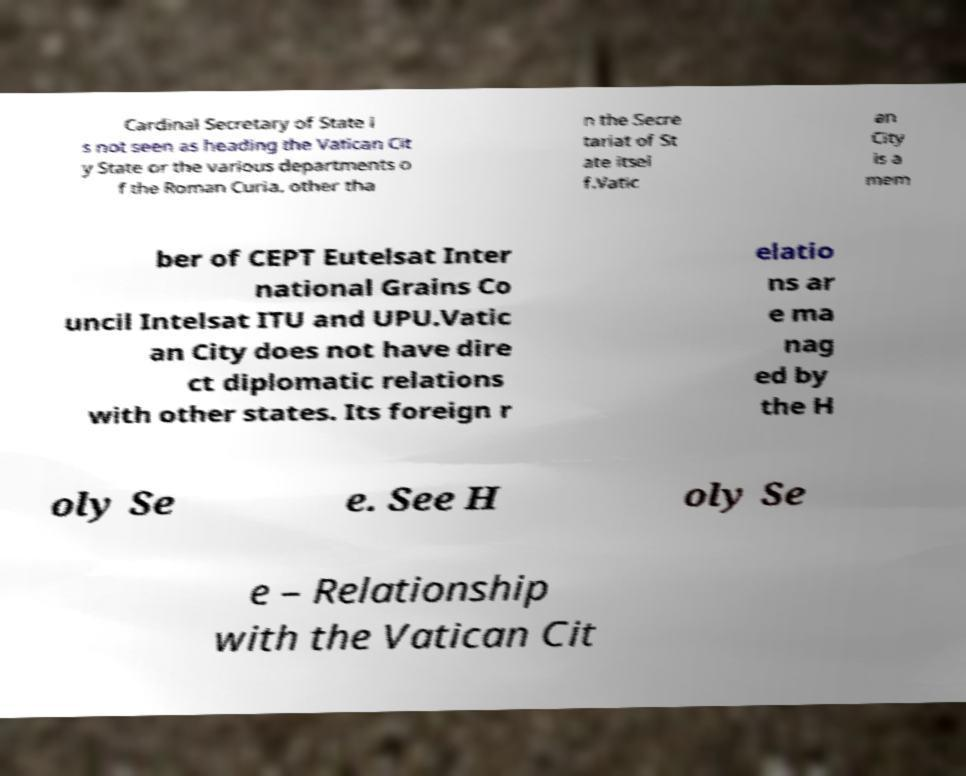Can you read and provide the text displayed in the image?This photo seems to have some interesting text. Can you extract and type it out for me? Cardinal Secretary of State i s not seen as heading the Vatican Cit y State or the various departments o f the Roman Curia, other tha n the Secre tariat of St ate itsel f.Vatic an City is a mem ber of CEPT Eutelsat Inter national Grains Co uncil Intelsat ITU and UPU.Vatic an City does not have dire ct diplomatic relations with other states. Its foreign r elatio ns ar e ma nag ed by the H oly Se e. See H oly Se e – Relationship with the Vatican Cit 